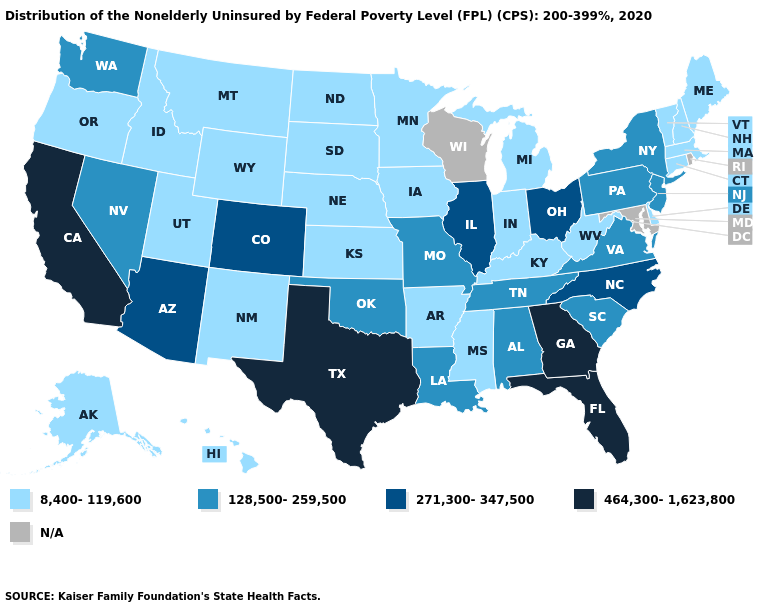Does Florida have the highest value in the South?
Be succinct. Yes. Name the states that have a value in the range 8,400-119,600?
Give a very brief answer. Alaska, Arkansas, Connecticut, Delaware, Hawaii, Idaho, Indiana, Iowa, Kansas, Kentucky, Maine, Massachusetts, Michigan, Minnesota, Mississippi, Montana, Nebraska, New Hampshire, New Mexico, North Dakota, Oregon, South Dakota, Utah, Vermont, West Virginia, Wyoming. What is the lowest value in states that border New Hampshire?
Quick response, please. 8,400-119,600. Name the states that have a value in the range 464,300-1,623,800?
Quick response, please. California, Florida, Georgia, Texas. Is the legend a continuous bar?
Keep it brief. No. Name the states that have a value in the range 464,300-1,623,800?
Give a very brief answer. California, Florida, Georgia, Texas. Name the states that have a value in the range 128,500-259,500?
Answer briefly. Alabama, Louisiana, Missouri, Nevada, New Jersey, New York, Oklahoma, Pennsylvania, South Carolina, Tennessee, Virginia, Washington. What is the highest value in the USA?
Short answer required. 464,300-1,623,800. Which states have the highest value in the USA?
Short answer required. California, Florida, Georgia, Texas. What is the highest value in states that border New York?
Short answer required. 128,500-259,500. Does New York have the highest value in the Northeast?
Short answer required. Yes. Name the states that have a value in the range 128,500-259,500?
Write a very short answer. Alabama, Louisiana, Missouri, Nevada, New Jersey, New York, Oklahoma, Pennsylvania, South Carolina, Tennessee, Virginia, Washington. What is the value of Michigan?
Quick response, please. 8,400-119,600. 